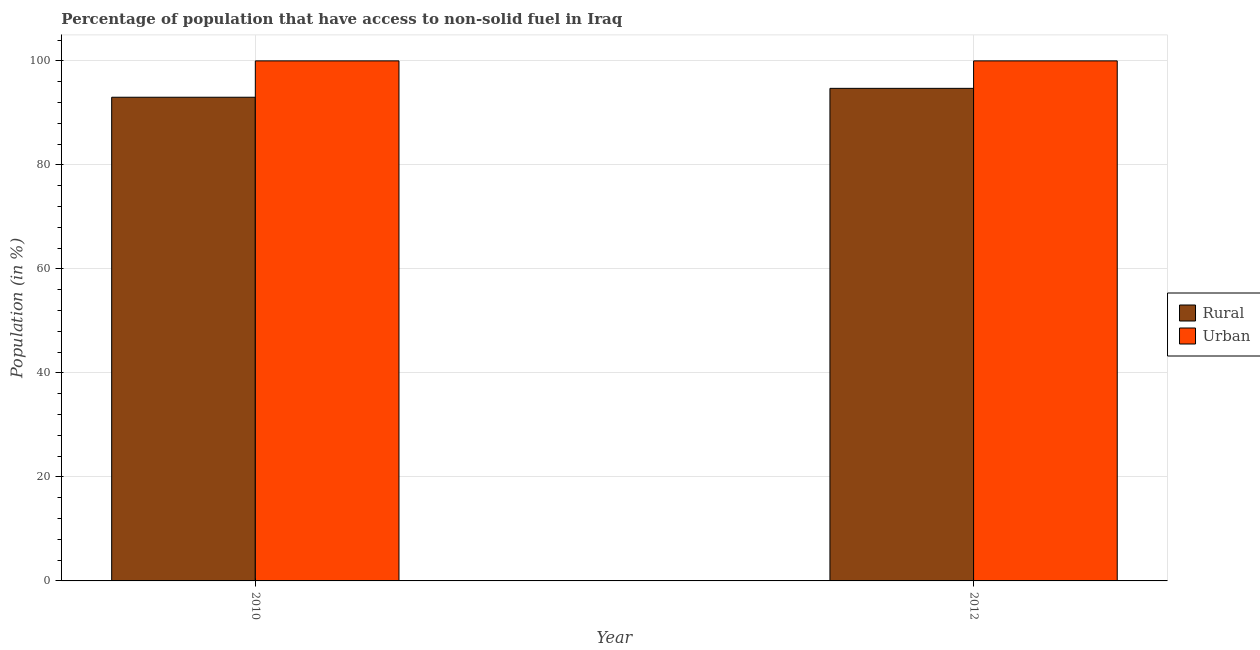Are the number of bars per tick equal to the number of legend labels?
Offer a terse response. Yes. Are the number of bars on each tick of the X-axis equal?
Provide a short and direct response. Yes. How many bars are there on the 1st tick from the right?
Make the answer very short. 2. In how many cases, is the number of bars for a given year not equal to the number of legend labels?
Make the answer very short. 0. What is the rural population in 2012?
Provide a succinct answer. 94.72. Across all years, what is the maximum urban population?
Offer a terse response. 100. Across all years, what is the minimum rural population?
Ensure brevity in your answer.  93.01. In which year was the rural population maximum?
Your answer should be very brief. 2012. What is the total urban population in the graph?
Offer a very short reply. 200. What is the difference between the rural population in 2010 and that in 2012?
Offer a terse response. -1.71. What is the difference between the rural population in 2012 and the urban population in 2010?
Offer a terse response. 1.71. What is the ratio of the rural population in 2010 to that in 2012?
Provide a succinct answer. 0.98. Is the urban population in 2010 less than that in 2012?
Provide a short and direct response. No. What does the 1st bar from the left in 2012 represents?
Ensure brevity in your answer.  Rural. What does the 1st bar from the right in 2010 represents?
Offer a very short reply. Urban. Are all the bars in the graph horizontal?
Ensure brevity in your answer.  No. What is the difference between two consecutive major ticks on the Y-axis?
Offer a very short reply. 20. Are the values on the major ticks of Y-axis written in scientific E-notation?
Make the answer very short. No. Where does the legend appear in the graph?
Keep it short and to the point. Center right. How many legend labels are there?
Offer a very short reply. 2. How are the legend labels stacked?
Keep it short and to the point. Vertical. What is the title of the graph?
Make the answer very short. Percentage of population that have access to non-solid fuel in Iraq. Does "RDB concessional" appear as one of the legend labels in the graph?
Offer a terse response. No. What is the label or title of the X-axis?
Make the answer very short. Year. What is the label or title of the Y-axis?
Your answer should be compact. Population (in %). What is the Population (in %) in Rural in 2010?
Provide a succinct answer. 93.01. What is the Population (in %) in Rural in 2012?
Your response must be concise. 94.72. Across all years, what is the maximum Population (in %) in Rural?
Your response must be concise. 94.72. Across all years, what is the maximum Population (in %) of Urban?
Offer a terse response. 100. Across all years, what is the minimum Population (in %) of Rural?
Give a very brief answer. 93.01. What is the total Population (in %) of Rural in the graph?
Provide a succinct answer. 187.72. What is the total Population (in %) in Urban in the graph?
Keep it short and to the point. 200. What is the difference between the Population (in %) of Rural in 2010 and that in 2012?
Provide a succinct answer. -1.71. What is the difference between the Population (in %) in Urban in 2010 and that in 2012?
Ensure brevity in your answer.  0. What is the difference between the Population (in %) of Rural in 2010 and the Population (in %) of Urban in 2012?
Give a very brief answer. -6.99. What is the average Population (in %) of Rural per year?
Your answer should be very brief. 93.86. In the year 2010, what is the difference between the Population (in %) in Rural and Population (in %) in Urban?
Your answer should be very brief. -6.99. In the year 2012, what is the difference between the Population (in %) of Rural and Population (in %) of Urban?
Your answer should be compact. -5.28. What is the ratio of the Population (in %) in Rural in 2010 to that in 2012?
Keep it short and to the point. 0.98. What is the difference between the highest and the second highest Population (in %) of Rural?
Keep it short and to the point. 1.71. What is the difference between the highest and the second highest Population (in %) in Urban?
Offer a terse response. 0. What is the difference between the highest and the lowest Population (in %) in Rural?
Your answer should be very brief. 1.71. What is the difference between the highest and the lowest Population (in %) of Urban?
Keep it short and to the point. 0. 